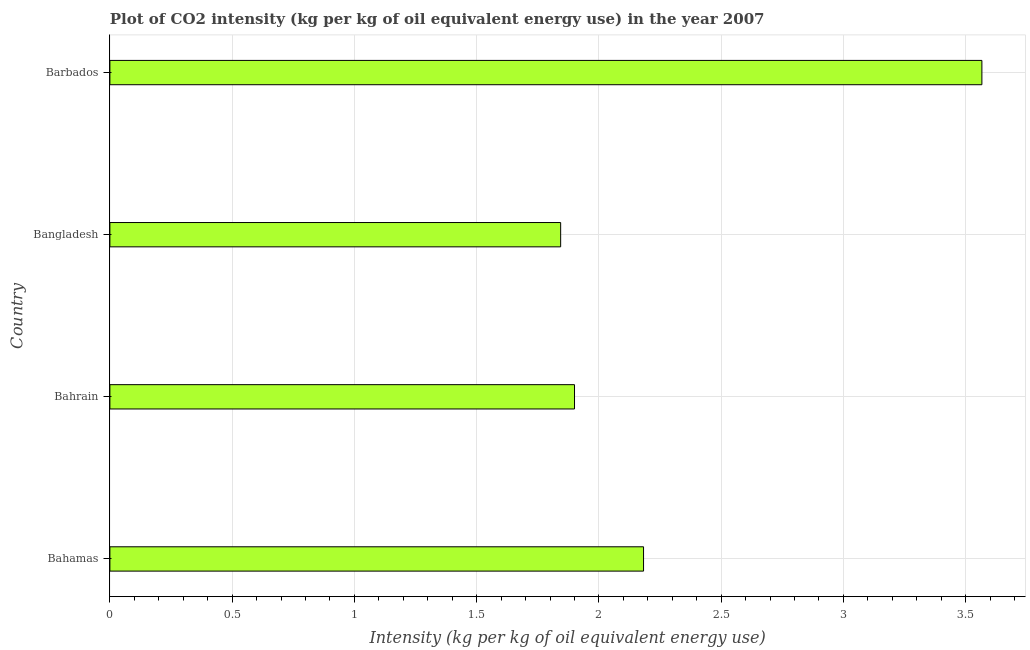Does the graph contain grids?
Your answer should be compact. Yes. What is the title of the graph?
Your answer should be compact. Plot of CO2 intensity (kg per kg of oil equivalent energy use) in the year 2007. What is the label or title of the X-axis?
Make the answer very short. Intensity (kg per kg of oil equivalent energy use). What is the co2 intensity in Bahrain?
Provide a succinct answer. 1.9. Across all countries, what is the maximum co2 intensity?
Offer a very short reply. 3.57. Across all countries, what is the minimum co2 intensity?
Offer a very short reply. 1.84. In which country was the co2 intensity maximum?
Make the answer very short. Barbados. What is the sum of the co2 intensity?
Provide a succinct answer. 9.49. What is the difference between the co2 intensity in Bahamas and Barbados?
Give a very brief answer. -1.38. What is the average co2 intensity per country?
Provide a succinct answer. 2.37. What is the median co2 intensity?
Provide a short and direct response. 2.04. What is the ratio of the co2 intensity in Bahrain to that in Bangladesh?
Give a very brief answer. 1.03. Is the co2 intensity in Bangladesh less than that in Barbados?
Make the answer very short. Yes. Is the difference between the co2 intensity in Bahamas and Bangladesh greater than the difference between any two countries?
Provide a succinct answer. No. What is the difference between the highest and the second highest co2 intensity?
Keep it short and to the point. 1.38. Is the sum of the co2 intensity in Bahrain and Bangladesh greater than the maximum co2 intensity across all countries?
Your answer should be compact. Yes. What is the difference between the highest and the lowest co2 intensity?
Keep it short and to the point. 1.72. Are all the bars in the graph horizontal?
Offer a very short reply. Yes. How many countries are there in the graph?
Make the answer very short. 4. What is the Intensity (kg per kg of oil equivalent energy use) in Bahamas?
Your answer should be compact. 2.18. What is the Intensity (kg per kg of oil equivalent energy use) in Bahrain?
Give a very brief answer. 1.9. What is the Intensity (kg per kg of oil equivalent energy use) of Bangladesh?
Provide a succinct answer. 1.84. What is the Intensity (kg per kg of oil equivalent energy use) in Barbados?
Offer a very short reply. 3.57. What is the difference between the Intensity (kg per kg of oil equivalent energy use) in Bahamas and Bahrain?
Provide a succinct answer. 0.28. What is the difference between the Intensity (kg per kg of oil equivalent energy use) in Bahamas and Bangladesh?
Your answer should be compact. 0.34. What is the difference between the Intensity (kg per kg of oil equivalent energy use) in Bahamas and Barbados?
Make the answer very short. -1.38. What is the difference between the Intensity (kg per kg of oil equivalent energy use) in Bahrain and Bangladesh?
Offer a very short reply. 0.06. What is the difference between the Intensity (kg per kg of oil equivalent energy use) in Bahrain and Barbados?
Provide a short and direct response. -1.67. What is the difference between the Intensity (kg per kg of oil equivalent energy use) in Bangladesh and Barbados?
Keep it short and to the point. -1.72. What is the ratio of the Intensity (kg per kg of oil equivalent energy use) in Bahamas to that in Bahrain?
Your answer should be compact. 1.15. What is the ratio of the Intensity (kg per kg of oil equivalent energy use) in Bahamas to that in Bangladesh?
Provide a short and direct response. 1.18. What is the ratio of the Intensity (kg per kg of oil equivalent energy use) in Bahamas to that in Barbados?
Provide a short and direct response. 0.61. What is the ratio of the Intensity (kg per kg of oil equivalent energy use) in Bahrain to that in Bangladesh?
Offer a terse response. 1.03. What is the ratio of the Intensity (kg per kg of oil equivalent energy use) in Bahrain to that in Barbados?
Offer a terse response. 0.53. What is the ratio of the Intensity (kg per kg of oil equivalent energy use) in Bangladesh to that in Barbados?
Ensure brevity in your answer.  0.52. 